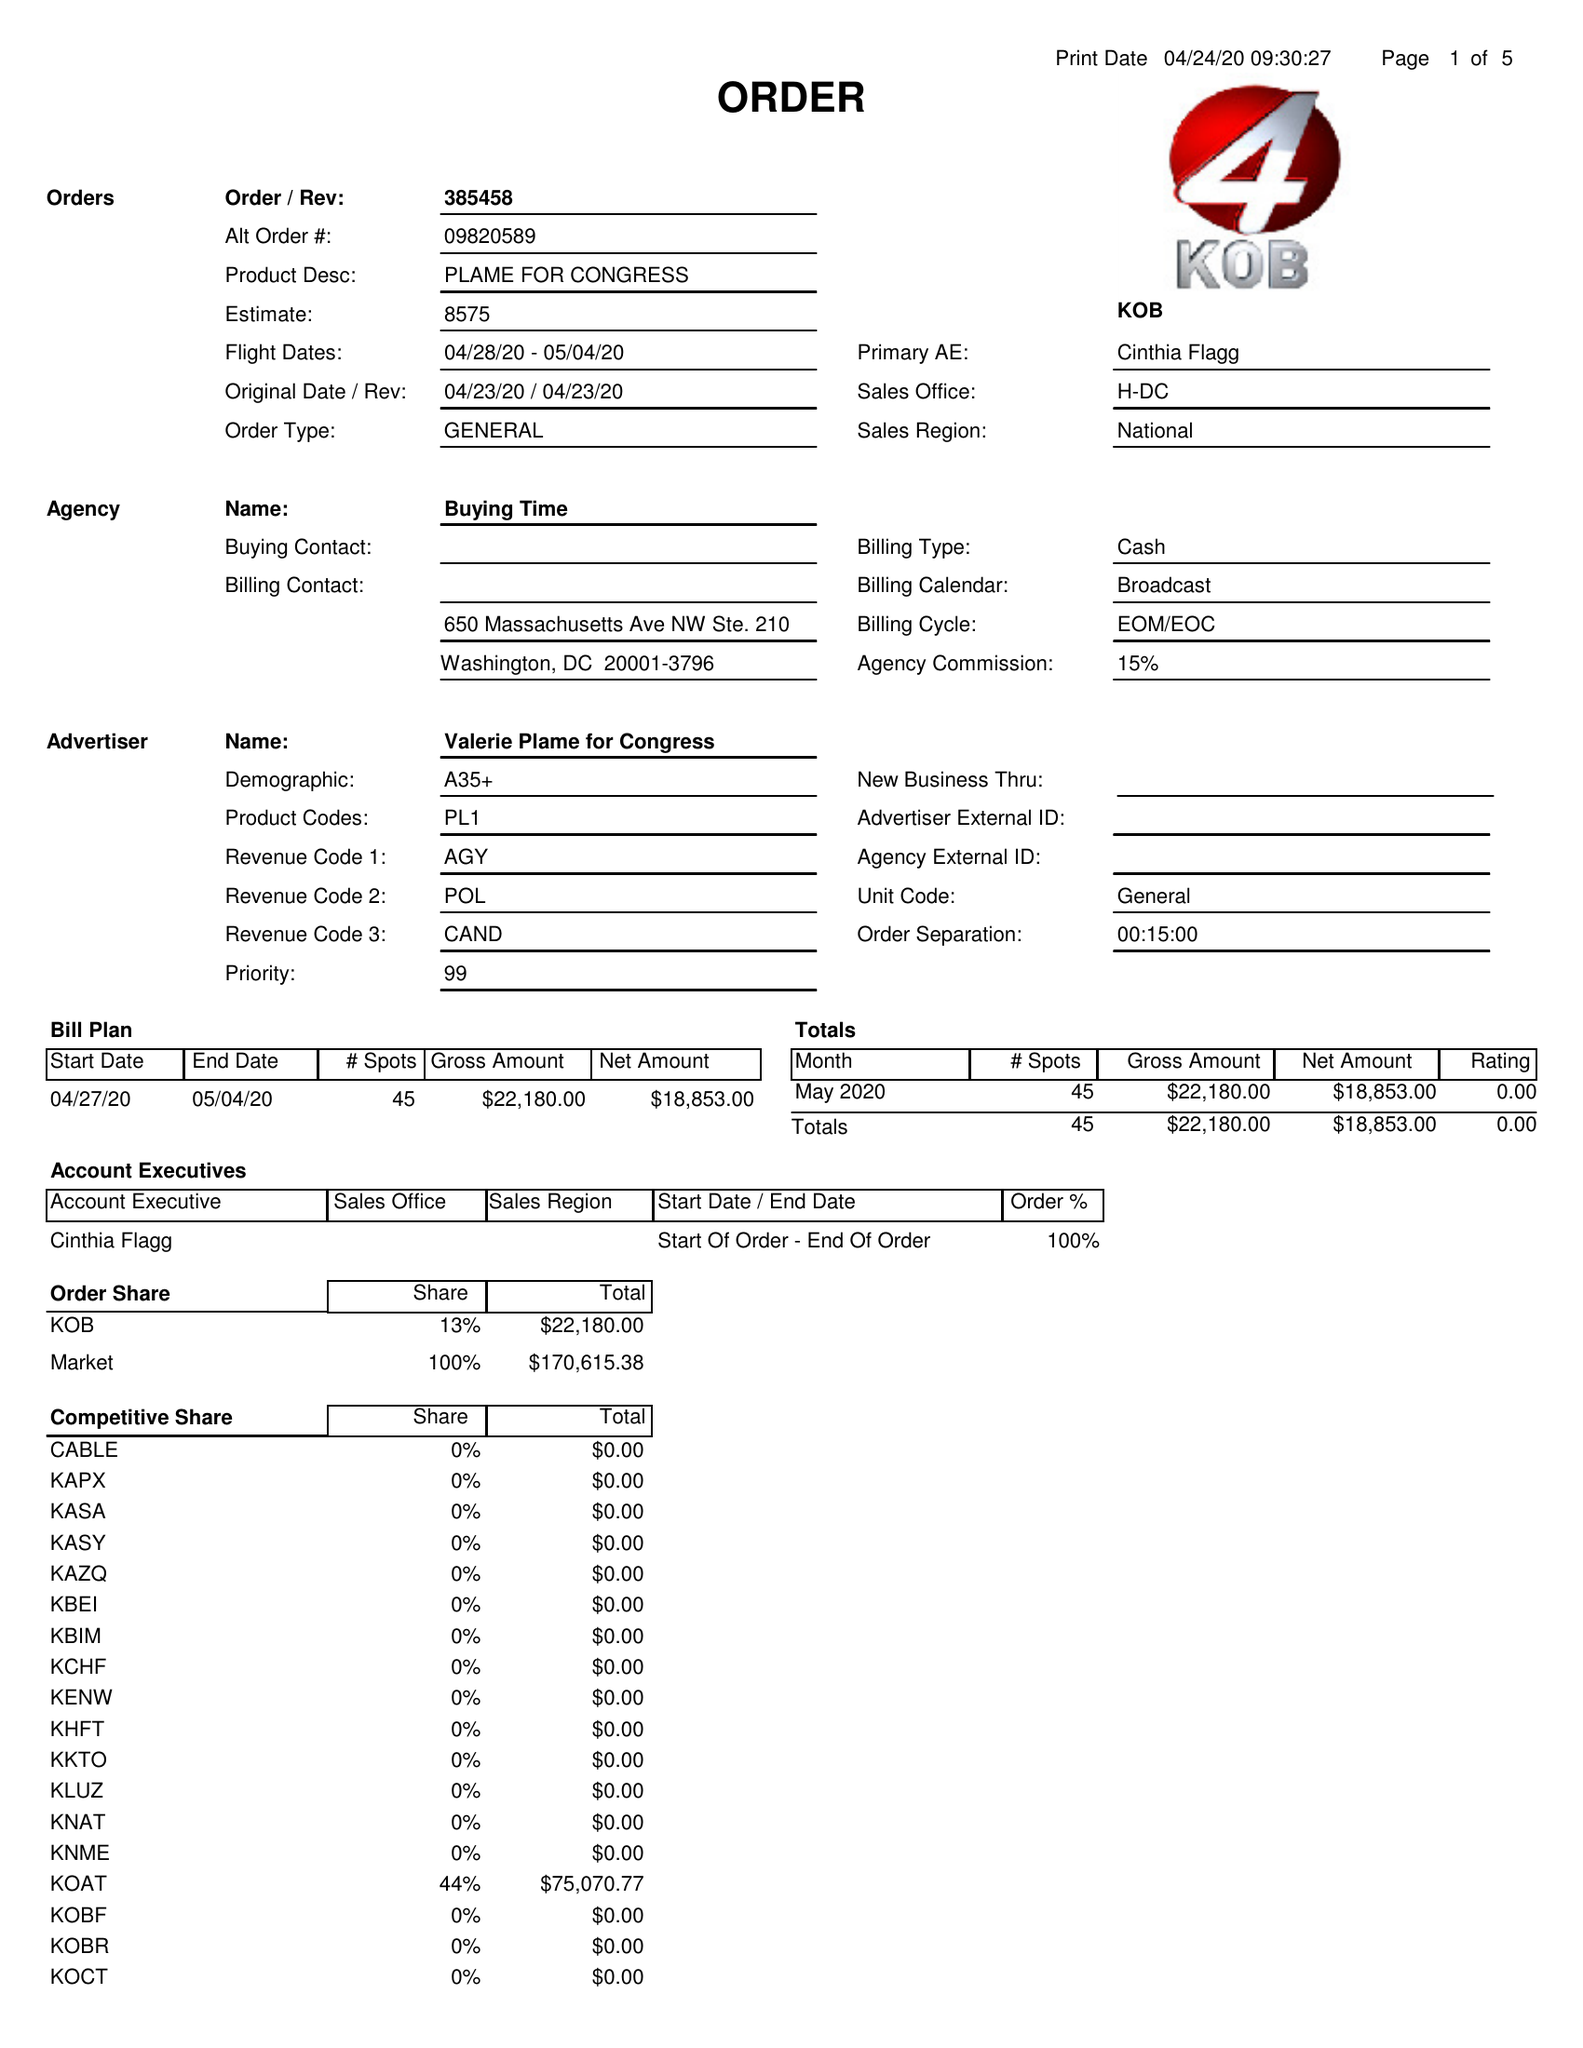What is the value for the contract_num?
Answer the question using a single word or phrase. 385458 